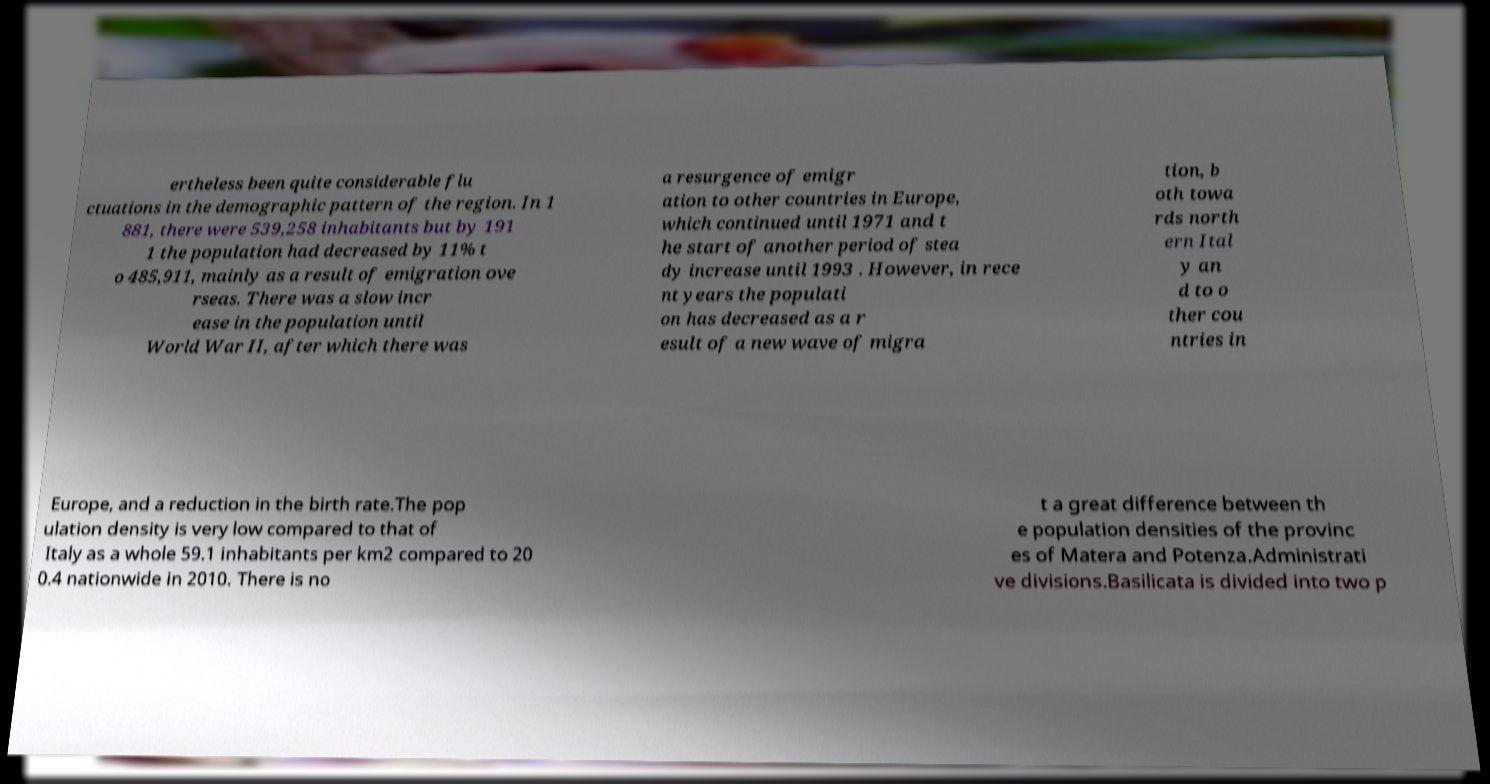Please read and relay the text visible in this image. What does it say? ertheless been quite considerable flu ctuations in the demographic pattern of the region. In 1 881, there were 539,258 inhabitants but by 191 1 the population had decreased by 11% t o 485,911, mainly as a result of emigration ove rseas. There was a slow incr ease in the population until World War II, after which there was a resurgence of emigr ation to other countries in Europe, which continued until 1971 and t he start of another period of stea dy increase until 1993 . However, in rece nt years the populati on has decreased as a r esult of a new wave of migra tion, b oth towa rds north ern Ital y an d to o ther cou ntries in Europe, and a reduction in the birth rate.The pop ulation density is very low compared to that of Italy as a whole 59.1 inhabitants per km2 compared to 20 0.4 nationwide in 2010. There is no t a great difference between th e population densities of the provinc es of Matera and Potenza.Administrati ve divisions.Basilicata is divided into two p 